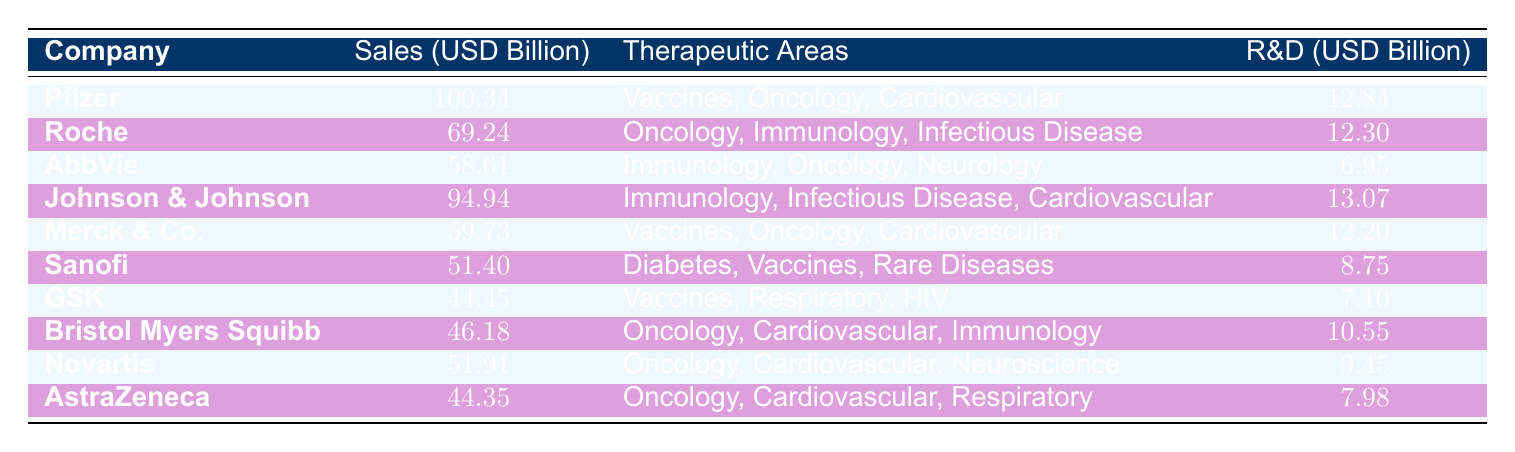What was the sales performance of Pfizer in 2022? According to the table, Pfizer's sales performance is listed as 100.34 billion USD.
Answer: 100.34 billion USD Which company had the lowest sales performance? By comparing the sales figures in the table, GSK shows the lowest sales performance at 44.45 billion USD.
Answer: GSK What is the total R&D investment made by the top three pharmaceutical companies? The R&D investments for the top three companies are Pfizer with 12.84 billion USD, Roche with 12.30 billion USD, and Johnson & Johnson with 13.07 billion USD. Summing these gives 12.84 + 12.30 + 13.07 = 38.21 billion USD.
Answer: 38.21 billion USD Is it true that AbbVie invests less in R&D than Merck & Co.? The R&D investment for AbbVie is 6.95 billion USD, while for Merck & Co. it is 12.20 billion USD. Since 6.95 is less than 12.20, the statement is true.
Answer: Yes What is the average sales performance of the pharmaceutical companies that focus on oncology? The companies focusing on oncology include Pfizer (100.34 billion), Roche (69.24 billion), AbbVie (58.61 billion), Merck & Co. (59.73 billion), Bristol Myers Squibb (46.18 billion), Novartis (51.91 billion), AstraZeneca (44.35 billion). Adding these values gives 100.34 + 69.24 + 58.61 + 59.73 + 46.18 + 51.91 + 44.35 = 430.36 billion USD. There are 7 data points, so the average is 430.36 / 7 = 61.48 billion USD.
Answer: 61.48 billion USD 